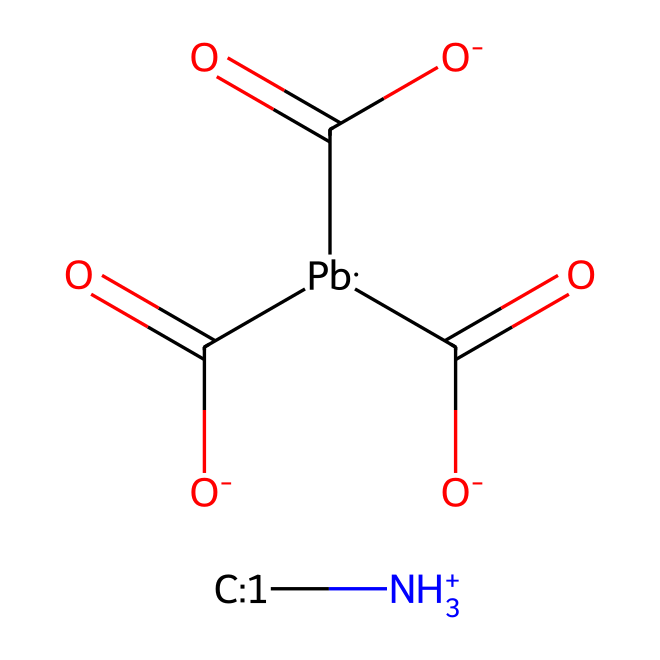What is the central metal atom in this structure? The SMILES representation shows "[Pb]", indicating that Lead is the central metal atom within the molecular structure.
Answer: Lead How many carboxylate groups are present? The notation "C(=O)[O-]" appears three times in the SMILES, representing three carboxylate groups attached to the Lead atom.
Answer: three What type of ionization does the ammonium group suggest? The "[NH3+]" indicates that the nitrogen is protonated, suggesting that the ammonium group is in a positively charged form.
Answer: ammonium How many total carbon atoms are found in the structure? The representation contains three carboxylate groups (each with one carbon) plus one methyl group (from [CH3:1]), totaling four carbon atoms (3+1).
Answer: four What functional groups are present in this molecular structure? The carboxylate groups and the ammonium ion are the key functional groups identified in the chemical, providing both acidic and basic properties.
Answer: carboxylate and ammonium What property of the quantum dots does the presence of lead suggest? Lead is often associated with high levels of light absorption and photonic properties beneficial for light-sensitive applications, enhancing detector performance.
Answer: high light absorption 